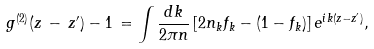Convert formula to latex. <formula><loc_0><loc_0><loc_500><loc_500>g ^ { ( 2 ) } ( z \, - \, z ^ { \prime } ) - 1 \, = \int \frac { d k } { 2 \pi n } \left [ 2 n _ { k } f _ { k } - ( 1 - f _ { k } ) \right ] e ^ { i k ( z - z ^ { \prime } ) } ,</formula> 